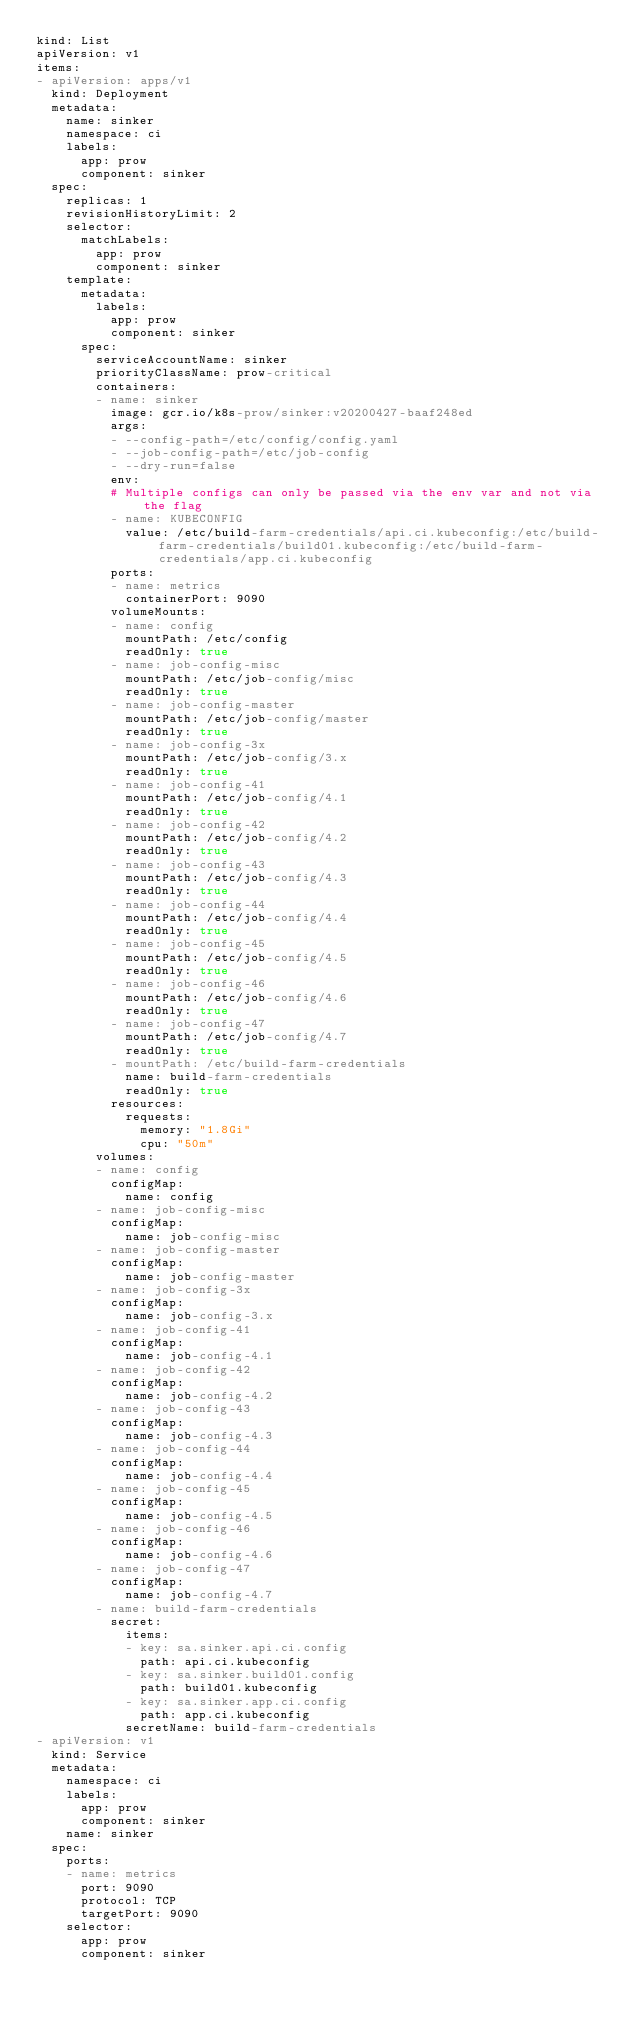<code> <loc_0><loc_0><loc_500><loc_500><_YAML_>kind: List
apiVersion: v1
items:
- apiVersion: apps/v1
  kind: Deployment
  metadata:
    name: sinker
    namespace: ci
    labels:
      app: prow
      component: sinker
  spec:
    replicas: 1
    revisionHistoryLimit: 2
    selector:
      matchLabels:
        app: prow
        component: sinker
    template:
      metadata:
        labels:
          app: prow
          component: sinker
      spec:
        serviceAccountName: sinker
        priorityClassName: prow-critical
        containers:
        - name: sinker
          image: gcr.io/k8s-prow/sinker:v20200427-baaf248ed
          args:
          - --config-path=/etc/config/config.yaml
          - --job-config-path=/etc/job-config
          - --dry-run=false
          env:
          # Multiple configs can only be passed via the env var and not via the flag
          - name: KUBECONFIG
            value: /etc/build-farm-credentials/api.ci.kubeconfig:/etc/build-farm-credentials/build01.kubeconfig:/etc/build-farm-credentials/app.ci.kubeconfig
          ports:
          - name: metrics
            containerPort: 9090
          volumeMounts:
          - name: config
            mountPath: /etc/config
            readOnly: true
          - name: job-config-misc
            mountPath: /etc/job-config/misc
            readOnly: true
          - name: job-config-master
            mountPath: /etc/job-config/master
            readOnly: true
          - name: job-config-3x
            mountPath: /etc/job-config/3.x
            readOnly: true
          - name: job-config-41
            mountPath: /etc/job-config/4.1
            readOnly: true
          - name: job-config-42
            mountPath: /etc/job-config/4.2
            readOnly: true
          - name: job-config-43
            mountPath: /etc/job-config/4.3
            readOnly: true
          - name: job-config-44
            mountPath: /etc/job-config/4.4
            readOnly: true
          - name: job-config-45
            mountPath: /etc/job-config/4.5
            readOnly: true
          - name: job-config-46
            mountPath: /etc/job-config/4.6
            readOnly: true
          - name: job-config-47
            mountPath: /etc/job-config/4.7
            readOnly: true
          - mountPath: /etc/build-farm-credentials
            name: build-farm-credentials
            readOnly: true
          resources:
            requests:
              memory: "1.8Gi"
              cpu: "50m"
        volumes:
        - name: config
          configMap:
            name: config
        - name: job-config-misc
          configMap:
            name: job-config-misc
        - name: job-config-master
          configMap:
            name: job-config-master
        - name: job-config-3x
          configMap:
            name: job-config-3.x
        - name: job-config-41
          configMap:
            name: job-config-4.1
        - name: job-config-42
          configMap:
            name: job-config-4.2
        - name: job-config-43
          configMap:
            name: job-config-4.3
        - name: job-config-44
          configMap:
            name: job-config-4.4
        - name: job-config-45
          configMap:
            name: job-config-4.5
        - name: job-config-46
          configMap:
            name: job-config-4.6
        - name: job-config-47
          configMap:
            name: job-config-4.7
        - name: build-farm-credentials
          secret:
            items:
            - key: sa.sinker.api.ci.config
              path: api.ci.kubeconfig
            - key: sa.sinker.build01.config
              path: build01.kubeconfig
            - key: sa.sinker.app.ci.config
              path: app.ci.kubeconfig
            secretName: build-farm-credentials
- apiVersion: v1
  kind: Service
  metadata:
    namespace: ci
    labels:
      app: prow
      component: sinker
    name: sinker
  spec:
    ports:
    - name: metrics
      port: 9090
      protocol: TCP
      targetPort: 9090
    selector:
      app: prow
      component: sinker
</code> 